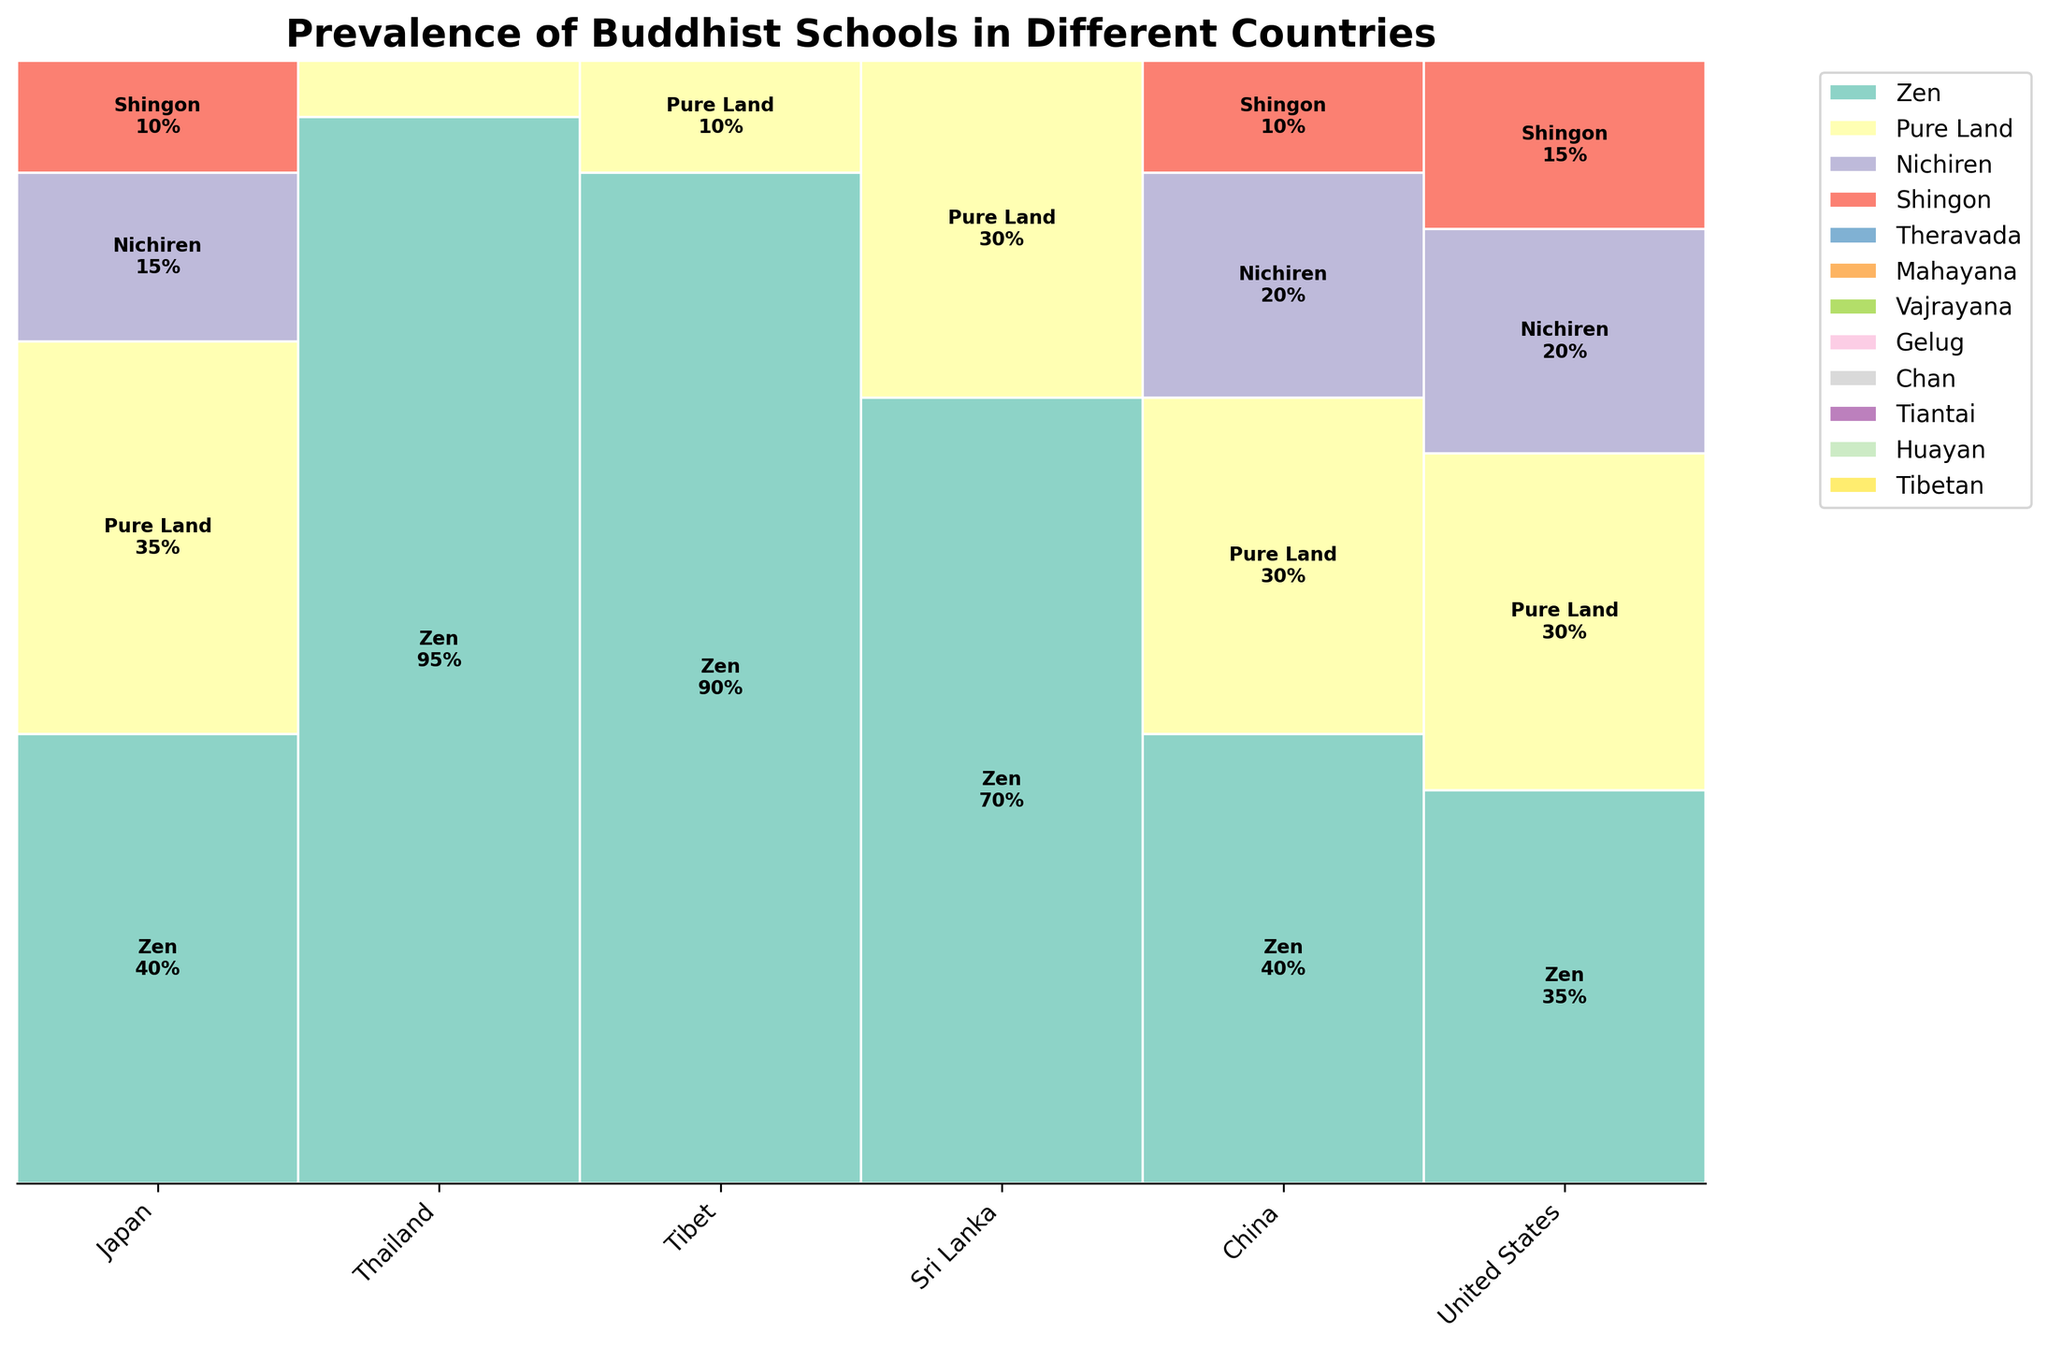What's the title of the plot? The title is typically found at the top of the plot, directly above the data. It describes the main point or focus of the figure.
Answer: Prevalence of Buddhist Schools in Different Countries Which country has the highest percentage of Theravada Buddhism? By observing the plot, we look for bars labeled "Theravada" and compare their heights. Theravada is most prevalent in Thailand with 95%.
Answer: Thailand Compare the prevalence of Zen Buddhism in Japan and United States. Which country has a higher percentage? First, locate the Zen section in Japan and the United States. Then, compare the heights of these sections across both countries. Japan's Zen is at 40%, while the United States' Zen is at 35%.
Answer: Japan How many countries show a significant presence (over 50%) of a single Buddhist school? For this, identify the sections that cover more than half the bar (over 50%) for each country. Count those which meet this criterion: Thailand (Theravada 95%) and Tibet (Vajrayana 90%).
Answer: 2 In Sri Lanka, what's the combined percentage for Mahayana and Theravada schools? Find the percentages for Mahayana and Theravada in Sri Lanka from the plot. Theravada is 70% and Mahayana is 30%. Sum them up to get the total.
Answer: 100% Which country has the most diverse distribution of Buddhist schools, and why? Diverse distribution means a country where the contributions from different schools are more balanced. By comparing the spread of sections for each country and noting the variations: The United States has Zen (35%), Tibetan (30%), Theravada (20%), and Pure Land (15%). This distribution is reasonably balanced compared to others.
Answer: United States Which country's representation includes the highest number of different Buddhist schools? Count the number of distinct school segments for each country by observing the visual sections within each country bar. China, with 4 segments (Chan, Pure Land, Tiantai, Huayan), has the highest variety.
Answer: China What percentage of Buddhism in China is accounted for by Chan and Pure Land combined? Sum the given percentages of Chan and Pure Land in China: Chan (40%) and Pure Land (30%) make a total of 70%.
Answer: 70% Is the Pure Land school more prevalent in the United States or Japan? Compare the heights of the Pure Land sections in both countries' bars. Japan has 35%, while the United States has 15%. Thus, it's more prevalent in Japan.
Answer: Japan 